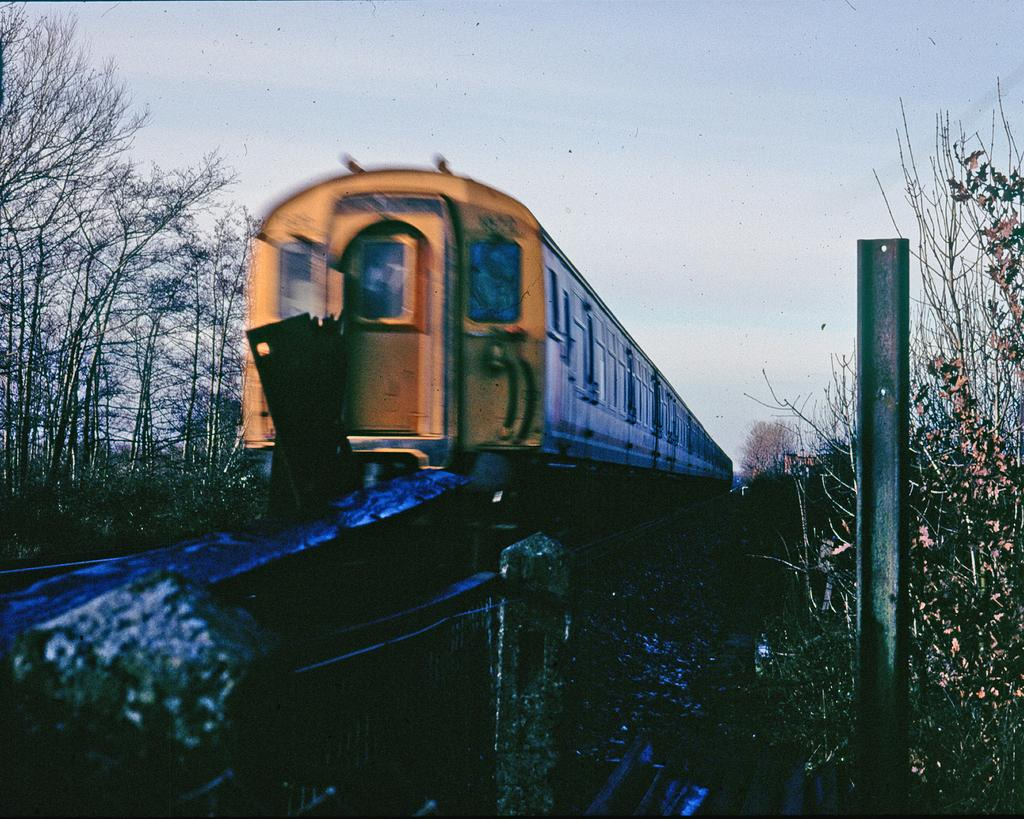What is the main subject of the image? There is a train in the image. What type of natural elements can be seen in the image? There are trees and plants in the image. Can you describe any specific objects in the image? There is a rod in the image, along with other objects. What can be seen in the background of the image? The sky is visible in the background of the image. What type of bomb can be seen in the image? There is no bomb present in the image. How does the train express anger in the image? Trains do not have the ability to express emotions like anger, as they are inanimate objects. 